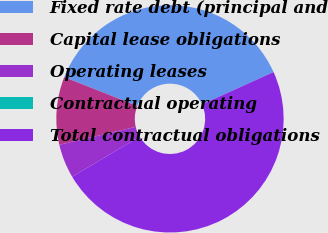<chart> <loc_0><loc_0><loc_500><loc_500><pie_chart><fcel>Fixed rate debt (principal and<fcel>Capital lease obligations<fcel>Operating leases<fcel>Contractual operating<fcel>Total contractual obligations<nl><fcel>37.27%<fcel>9.65%<fcel>4.83%<fcel>0.0%<fcel>48.25%<nl></chart> 